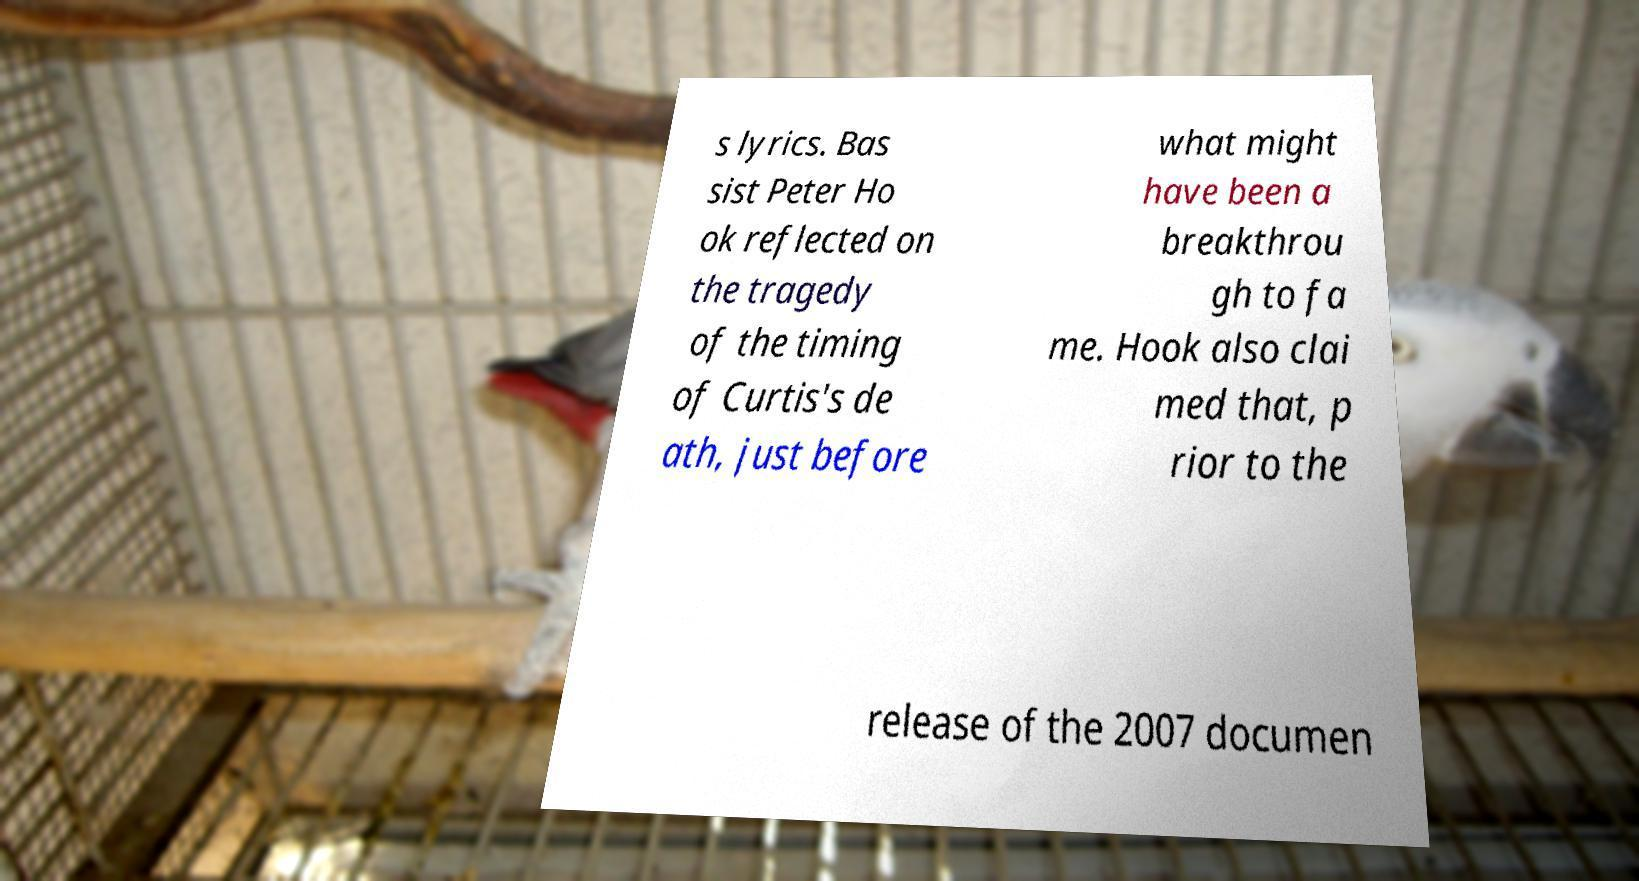I need the written content from this picture converted into text. Can you do that? s lyrics. Bas sist Peter Ho ok reflected on the tragedy of the timing of Curtis's de ath, just before what might have been a breakthrou gh to fa me. Hook also clai med that, p rior to the release of the 2007 documen 